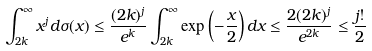<formula> <loc_0><loc_0><loc_500><loc_500>\int _ { 2 k } ^ { \infty } x ^ { j } d \sigma ( x ) \leq \frac { ( 2 k ) ^ { j } } { e ^ { k } } \int _ { 2 k } ^ { \infty } \exp \left ( - \frac { x } { 2 } \right ) d x \leq \frac { 2 ( 2 k ) ^ { j } } { e ^ { 2 k } } \leq \frac { j ! } { 2 }</formula> 